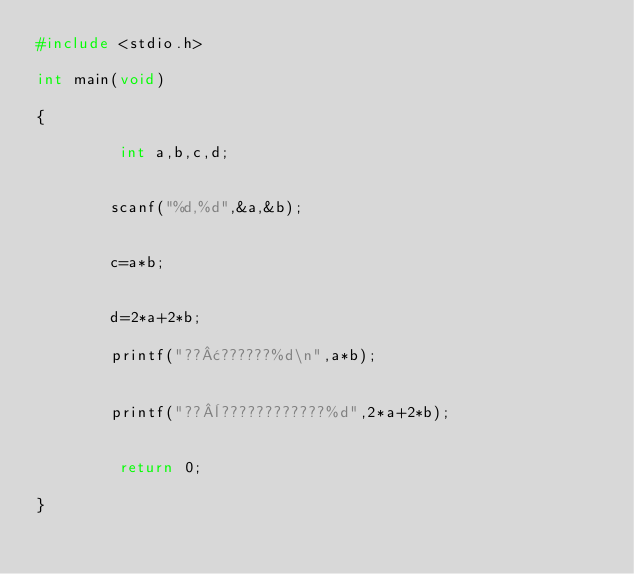Convert code to text. <code><loc_0><loc_0><loc_500><loc_500><_C_>#include <stdio.h>

int main(void)

{

         int a,b,c,d;


        scanf("%d,%d",&a,&b);


        c=a*b;


        d=2*a+2*b;

        printf("??¢??????%d\n",a*b);


        printf("??¨????????????%d",2*a+2*b);


         return 0;

}</code> 